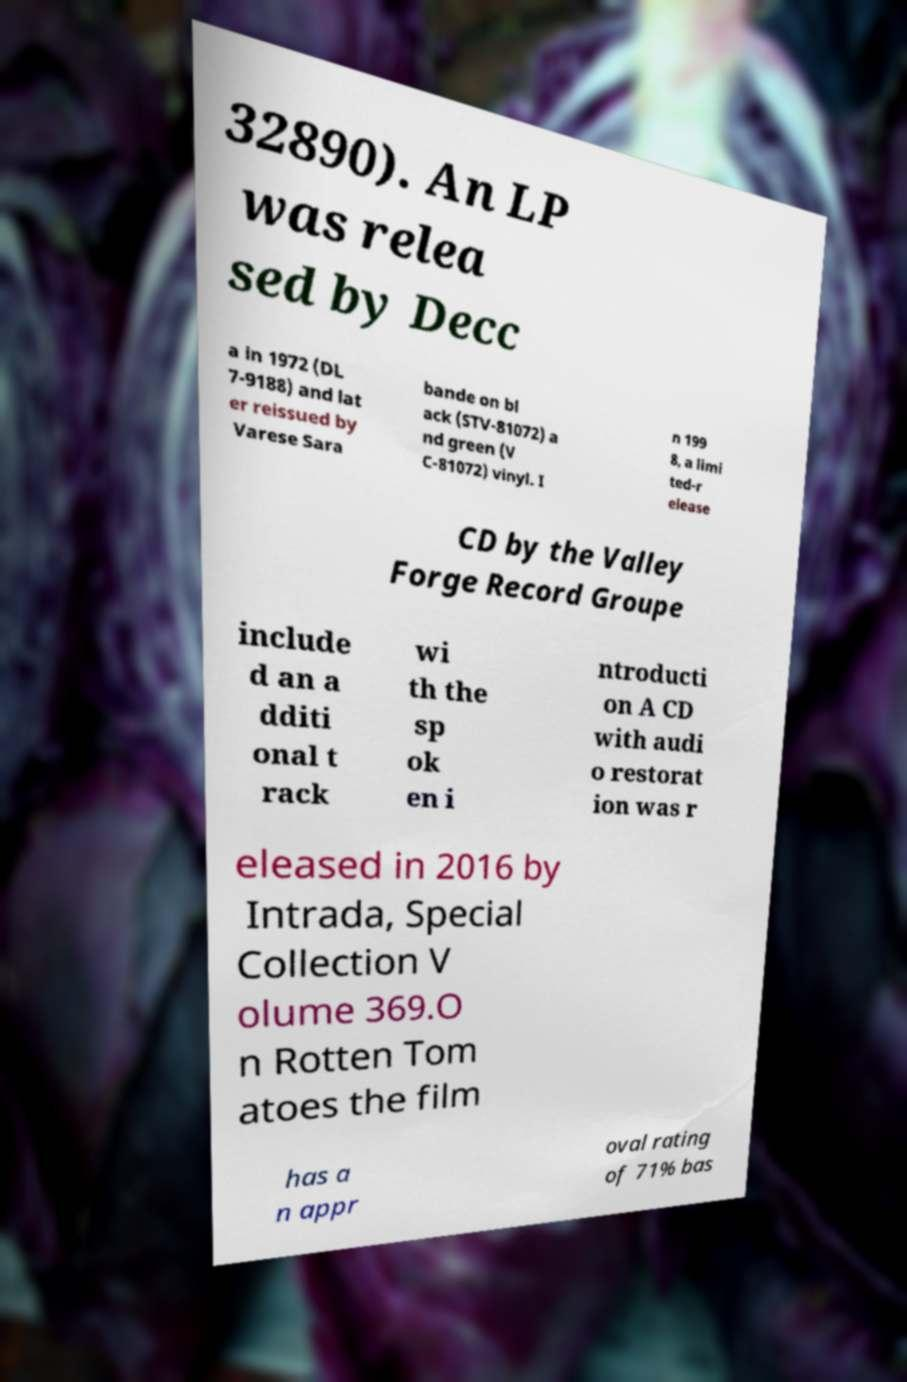Can you accurately transcribe the text from the provided image for me? 32890). An LP was relea sed by Decc a in 1972 (DL 7-9188) and lat er reissued by Varese Sara bande on bl ack (STV-81072) a nd green (V C-81072) vinyl. I n 199 8, a limi ted-r elease CD by the Valley Forge Record Groupe include d an a dditi onal t rack wi th the sp ok en i ntroducti on A CD with audi o restorat ion was r eleased in 2016 by Intrada, Special Collection V olume 369.O n Rotten Tom atoes the film has a n appr oval rating of 71% bas 